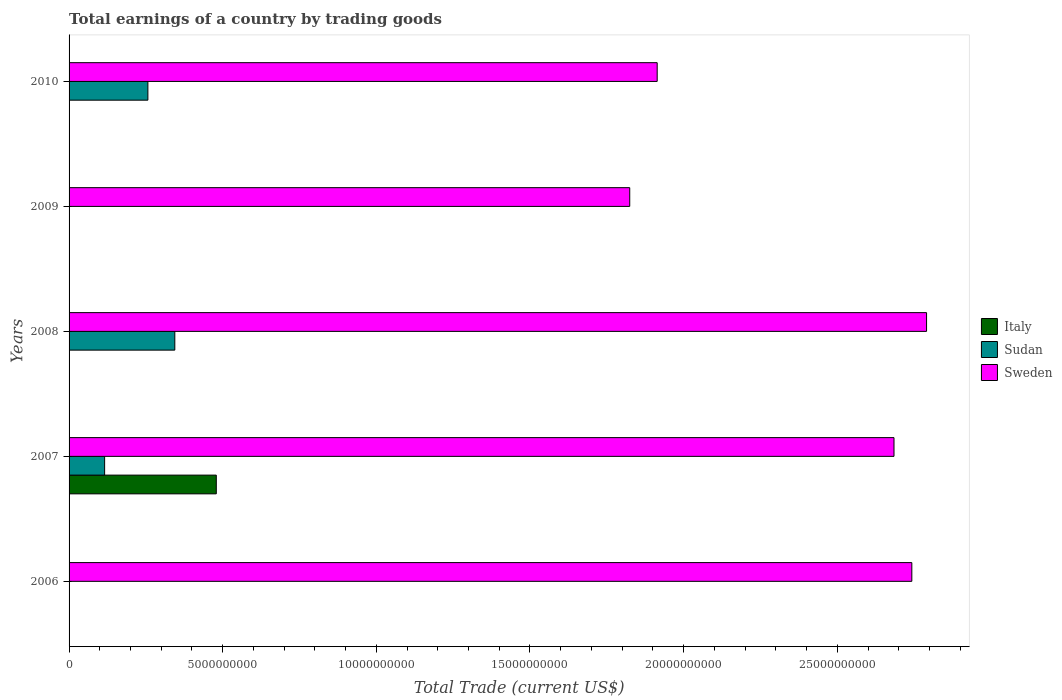How many different coloured bars are there?
Provide a succinct answer. 3. Are the number of bars per tick equal to the number of legend labels?
Keep it short and to the point. No. In how many cases, is the number of bars for a given year not equal to the number of legend labels?
Make the answer very short. 4. What is the total earnings in Sweden in 2008?
Keep it short and to the point. 2.79e+1. Across all years, what is the maximum total earnings in Sudan?
Provide a short and direct response. 3.44e+09. Across all years, what is the minimum total earnings in Sweden?
Your answer should be compact. 1.82e+1. What is the total total earnings in Sweden in the graph?
Give a very brief answer. 1.20e+11. What is the difference between the total earnings in Sudan in 2008 and that in 2010?
Ensure brevity in your answer.  8.76e+08. What is the difference between the total earnings in Sudan in 2006 and the total earnings in Sweden in 2009?
Offer a very short reply. -1.82e+1. What is the average total earnings in Italy per year?
Your answer should be compact. 9.58e+08. In the year 2008, what is the difference between the total earnings in Sweden and total earnings in Sudan?
Your answer should be compact. 2.45e+1. In how many years, is the total earnings in Sweden greater than 2000000000 US$?
Give a very brief answer. 5. What is the ratio of the total earnings in Sudan in 2008 to that in 2010?
Ensure brevity in your answer.  1.34. Is the difference between the total earnings in Sweden in 2007 and 2010 greater than the difference between the total earnings in Sudan in 2007 and 2010?
Keep it short and to the point. Yes. What is the difference between the highest and the second highest total earnings in Sudan?
Keep it short and to the point. 8.76e+08. What is the difference between the highest and the lowest total earnings in Italy?
Your answer should be compact. 4.79e+09. In how many years, is the total earnings in Sweden greater than the average total earnings in Sweden taken over all years?
Your answer should be very brief. 3. Is the sum of the total earnings in Sudan in 2007 and 2010 greater than the maximum total earnings in Sweden across all years?
Offer a very short reply. No. Is it the case that in every year, the sum of the total earnings in Sudan and total earnings in Sweden is greater than the total earnings in Italy?
Your answer should be very brief. Yes. Are all the bars in the graph horizontal?
Make the answer very short. Yes. Does the graph contain grids?
Keep it short and to the point. No. Where does the legend appear in the graph?
Give a very brief answer. Center right. How many legend labels are there?
Offer a terse response. 3. What is the title of the graph?
Your answer should be compact. Total earnings of a country by trading goods. What is the label or title of the X-axis?
Your answer should be compact. Total Trade (current US$). What is the Total Trade (current US$) of Italy in 2006?
Your answer should be very brief. 0. What is the Total Trade (current US$) of Sweden in 2006?
Your answer should be very brief. 2.74e+1. What is the Total Trade (current US$) in Italy in 2007?
Offer a very short reply. 4.79e+09. What is the Total Trade (current US$) of Sudan in 2007?
Provide a short and direct response. 1.16e+09. What is the Total Trade (current US$) in Sweden in 2007?
Provide a short and direct response. 2.68e+1. What is the Total Trade (current US$) in Sudan in 2008?
Offer a very short reply. 3.44e+09. What is the Total Trade (current US$) in Sweden in 2008?
Your response must be concise. 2.79e+1. What is the Total Trade (current US$) in Sweden in 2009?
Offer a very short reply. 1.82e+1. What is the Total Trade (current US$) in Italy in 2010?
Provide a succinct answer. 0. What is the Total Trade (current US$) in Sudan in 2010?
Keep it short and to the point. 2.56e+09. What is the Total Trade (current US$) of Sweden in 2010?
Your answer should be compact. 1.91e+1. Across all years, what is the maximum Total Trade (current US$) in Italy?
Offer a terse response. 4.79e+09. Across all years, what is the maximum Total Trade (current US$) in Sudan?
Your answer should be very brief. 3.44e+09. Across all years, what is the maximum Total Trade (current US$) of Sweden?
Your answer should be very brief. 2.79e+1. Across all years, what is the minimum Total Trade (current US$) of Italy?
Keep it short and to the point. 0. Across all years, what is the minimum Total Trade (current US$) of Sweden?
Your answer should be compact. 1.82e+1. What is the total Total Trade (current US$) of Italy in the graph?
Your response must be concise. 4.79e+09. What is the total Total Trade (current US$) of Sudan in the graph?
Give a very brief answer. 7.16e+09. What is the total Total Trade (current US$) in Sweden in the graph?
Offer a terse response. 1.20e+11. What is the difference between the Total Trade (current US$) of Sweden in 2006 and that in 2007?
Provide a short and direct response. 5.80e+08. What is the difference between the Total Trade (current US$) in Sweden in 2006 and that in 2008?
Keep it short and to the point. -4.79e+08. What is the difference between the Total Trade (current US$) of Sweden in 2006 and that in 2009?
Your response must be concise. 9.18e+09. What is the difference between the Total Trade (current US$) in Sweden in 2006 and that in 2010?
Give a very brief answer. 8.29e+09. What is the difference between the Total Trade (current US$) of Sudan in 2007 and that in 2008?
Ensure brevity in your answer.  -2.28e+09. What is the difference between the Total Trade (current US$) in Sweden in 2007 and that in 2008?
Ensure brevity in your answer.  -1.06e+09. What is the difference between the Total Trade (current US$) of Sweden in 2007 and that in 2009?
Your answer should be compact. 8.60e+09. What is the difference between the Total Trade (current US$) of Sudan in 2007 and that in 2010?
Keep it short and to the point. -1.41e+09. What is the difference between the Total Trade (current US$) of Sweden in 2007 and that in 2010?
Offer a very short reply. 7.71e+09. What is the difference between the Total Trade (current US$) of Sweden in 2008 and that in 2009?
Offer a terse response. 9.66e+09. What is the difference between the Total Trade (current US$) of Sudan in 2008 and that in 2010?
Your response must be concise. 8.76e+08. What is the difference between the Total Trade (current US$) of Sweden in 2008 and that in 2010?
Your response must be concise. 8.77e+09. What is the difference between the Total Trade (current US$) of Sweden in 2009 and that in 2010?
Make the answer very short. -8.94e+08. What is the difference between the Total Trade (current US$) of Italy in 2007 and the Total Trade (current US$) of Sudan in 2008?
Make the answer very short. 1.35e+09. What is the difference between the Total Trade (current US$) of Italy in 2007 and the Total Trade (current US$) of Sweden in 2008?
Give a very brief answer. -2.31e+1. What is the difference between the Total Trade (current US$) in Sudan in 2007 and the Total Trade (current US$) in Sweden in 2008?
Keep it short and to the point. -2.67e+1. What is the difference between the Total Trade (current US$) in Italy in 2007 and the Total Trade (current US$) in Sweden in 2009?
Your response must be concise. -1.35e+1. What is the difference between the Total Trade (current US$) of Sudan in 2007 and the Total Trade (current US$) of Sweden in 2009?
Your response must be concise. -1.71e+1. What is the difference between the Total Trade (current US$) of Italy in 2007 and the Total Trade (current US$) of Sudan in 2010?
Your response must be concise. 2.23e+09. What is the difference between the Total Trade (current US$) in Italy in 2007 and the Total Trade (current US$) in Sweden in 2010?
Ensure brevity in your answer.  -1.43e+1. What is the difference between the Total Trade (current US$) in Sudan in 2007 and the Total Trade (current US$) in Sweden in 2010?
Offer a very short reply. -1.80e+1. What is the difference between the Total Trade (current US$) in Sudan in 2008 and the Total Trade (current US$) in Sweden in 2009?
Keep it short and to the point. -1.48e+1. What is the difference between the Total Trade (current US$) of Sudan in 2008 and the Total Trade (current US$) of Sweden in 2010?
Offer a terse response. -1.57e+1. What is the average Total Trade (current US$) in Italy per year?
Provide a short and direct response. 9.58e+08. What is the average Total Trade (current US$) in Sudan per year?
Provide a short and direct response. 1.43e+09. What is the average Total Trade (current US$) of Sweden per year?
Make the answer very short. 2.39e+1. In the year 2007, what is the difference between the Total Trade (current US$) in Italy and Total Trade (current US$) in Sudan?
Offer a very short reply. 3.63e+09. In the year 2007, what is the difference between the Total Trade (current US$) of Italy and Total Trade (current US$) of Sweden?
Your response must be concise. -2.21e+1. In the year 2007, what is the difference between the Total Trade (current US$) of Sudan and Total Trade (current US$) of Sweden?
Make the answer very short. -2.57e+1. In the year 2008, what is the difference between the Total Trade (current US$) of Sudan and Total Trade (current US$) of Sweden?
Provide a succinct answer. -2.45e+1. In the year 2010, what is the difference between the Total Trade (current US$) of Sudan and Total Trade (current US$) of Sweden?
Offer a very short reply. -1.66e+1. What is the ratio of the Total Trade (current US$) in Sweden in 2006 to that in 2007?
Offer a very short reply. 1.02. What is the ratio of the Total Trade (current US$) of Sweden in 2006 to that in 2008?
Your response must be concise. 0.98. What is the ratio of the Total Trade (current US$) in Sweden in 2006 to that in 2009?
Ensure brevity in your answer.  1.5. What is the ratio of the Total Trade (current US$) of Sweden in 2006 to that in 2010?
Ensure brevity in your answer.  1.43. What is the ratio of the Total Trade (current US$) in Sudan in 2007 to that in 2008?
Provide a succinct answer. 0.34. What is the ratio of the Total Trade (current US$) in Sweden in 2007 to that in 2008?
Offer a terse response. 0.96. What is the ratio of the Total Trade (current US$) in Sweden in 2007 to that in 2009?
Ensure brevity in your answer.  1.47. What is the ratio of the Total Trade (current US$) of Sudan in 2007 to that in 2010?
Your answer should be very brief. 0.45. What is the ratio of the Total Trade (current US$) of Sweden in 2007 to that in 2010?
Give a very brief answer. 1.4. What is the ratio of the Total Trade (current US$) of Sweden in 2008 to that in 2009?
Provide a succinct answer. 1.53. What is the ratio of the Total Trade (current US$) of Sudan in 2008 to that in 2010?
Your answer should be compact. 1.34. What is the ratio of the Total Trade (current US$) of Sweden in 2008 to that in 2010?
Provide a short and direct response. 1.46. What is the ratio of the Total Trade (current US$) of Sweden in 2009 to that in 2010?
Provide a succinct answer. 0.95. What is the difference between the highest and the second highest Total Trade (current US$) of Sudan?
Make the answer very short. 8.76e+08. What is the difference between the highest and the second highest Total Trade (current US$) of Sweden?
Your answer should be compact. 4.79e+08. What is the difference between the highest and the lowest Total Trade (current US$) of Italy?
Make the answer very short. 4.79e+09. What is the difference between the highest and the lowest Total Trade (current US$) of Sudan?
Provide a short and direct response. 3.44e+09. What is the difference between the highest and the lowest Total Trade (current US$) in Sweden?
Keep it short and to the point. 9.66e+09. 